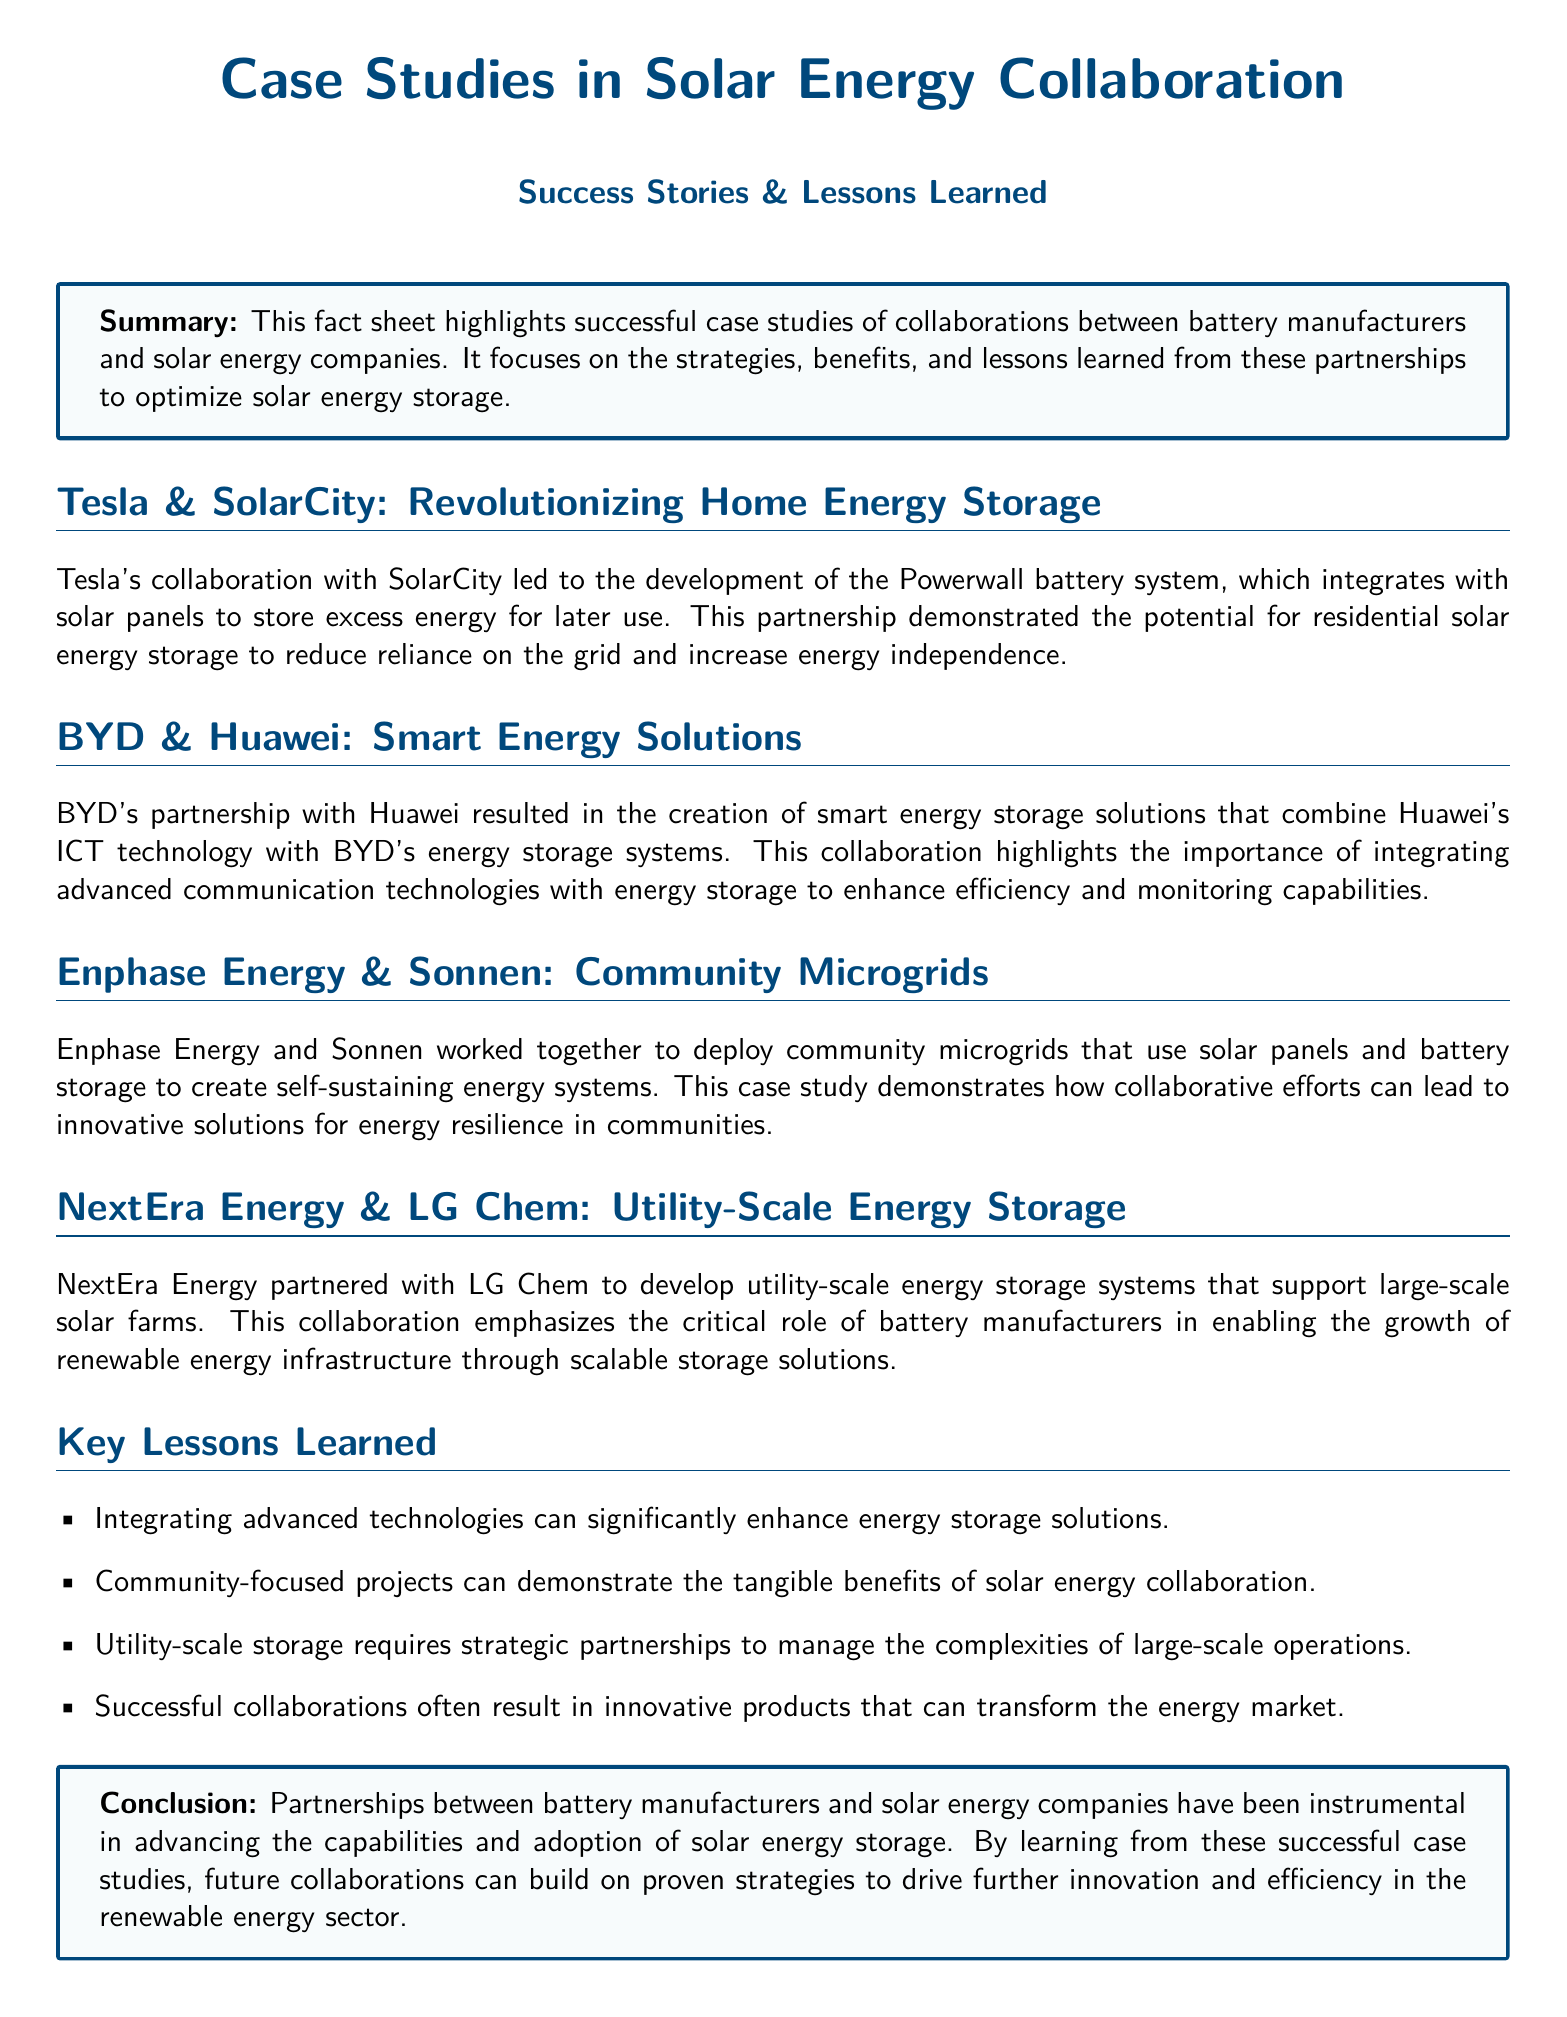What is the name of the battery system developed by Tesla and SolarCity? The document mentions that the collaboration led to the development of the Powerwall battery system.
Answer: Powerwall What company did BYD collaborate with for smart energy solutions? The document states that BYD partnered with Huawei for the creation of smart energy storage solutions.
Answer: Huawei What type of energy system did Enphase Energy and Sonnen deploy? The collaboration focused on deploying community microgrids that integrate solar panels and battery storage.
Answer: Community microgrids Which two companies collaborated on utility-scale energy storage? The document specifies that NextEra Energy partnered with LG Chem for developing utility-scale energy storage systems.
Answer: NextEra Energy and LG Chem What is one key lesson learned from solar energy collaborations? The document lists that integrating advanced technologies can significantly enhance energy storage solutions as a key lesson.
Answer: Integrating advanced technologies What does the conclusion suggest about partnerships between battery manufacturers and solar companies? The conclusion indicates that such partnerships have been instrumental in advancing capabilities and adoption in solar energy storage.
Answer: Instrumental in advancing capabilities What is the primary focus of the case studies highlighted in the fact sheet? The document indicates that it focuses on strategies, benefits, and lessons learned from partnerships to optimize solar energy storage.
Answer: Strategies, benefits, and lessons learned What is the color of the background used in the title section? The document does not specify a direct color name, but it uses a light blue background for the tcolorbox.
Answer: Light blue How many lessons learned are mentioned in the document? The document lists a total of four important lessons learned from the case studies.
Answer: Four 